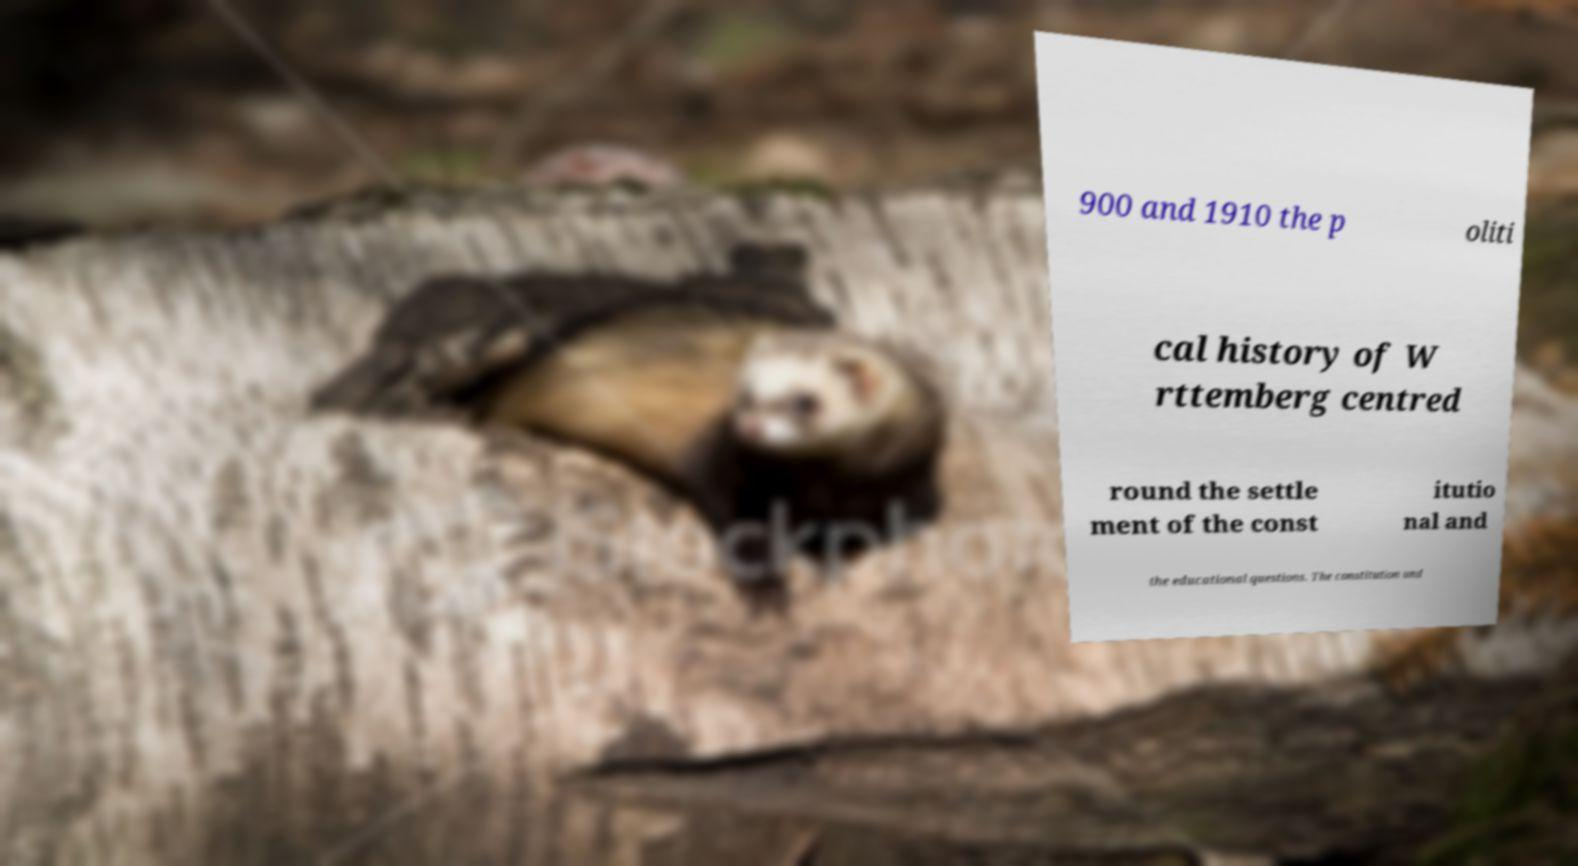Could you assist in decoding the text presented in this image and type it out clearly? 900 and 1910 the p oliti cal history of W rttemberg centred round the settle ment of the const itutio nal and the educational questions. The constitution und 